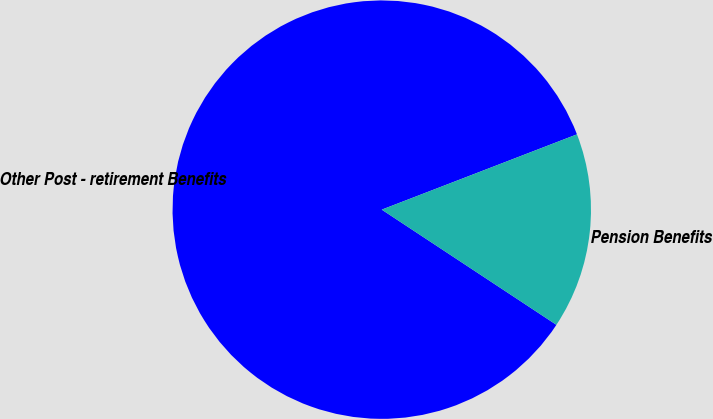Convert chart to OTSL. <chart><loc_0><loc_0><loc_500><loc_500><pie_chart><fcel>Other Post - retirement Benefits<fcel>Pension Benefits<nl><fcel>84.86%<fcel>15.14%<nl></chart> 